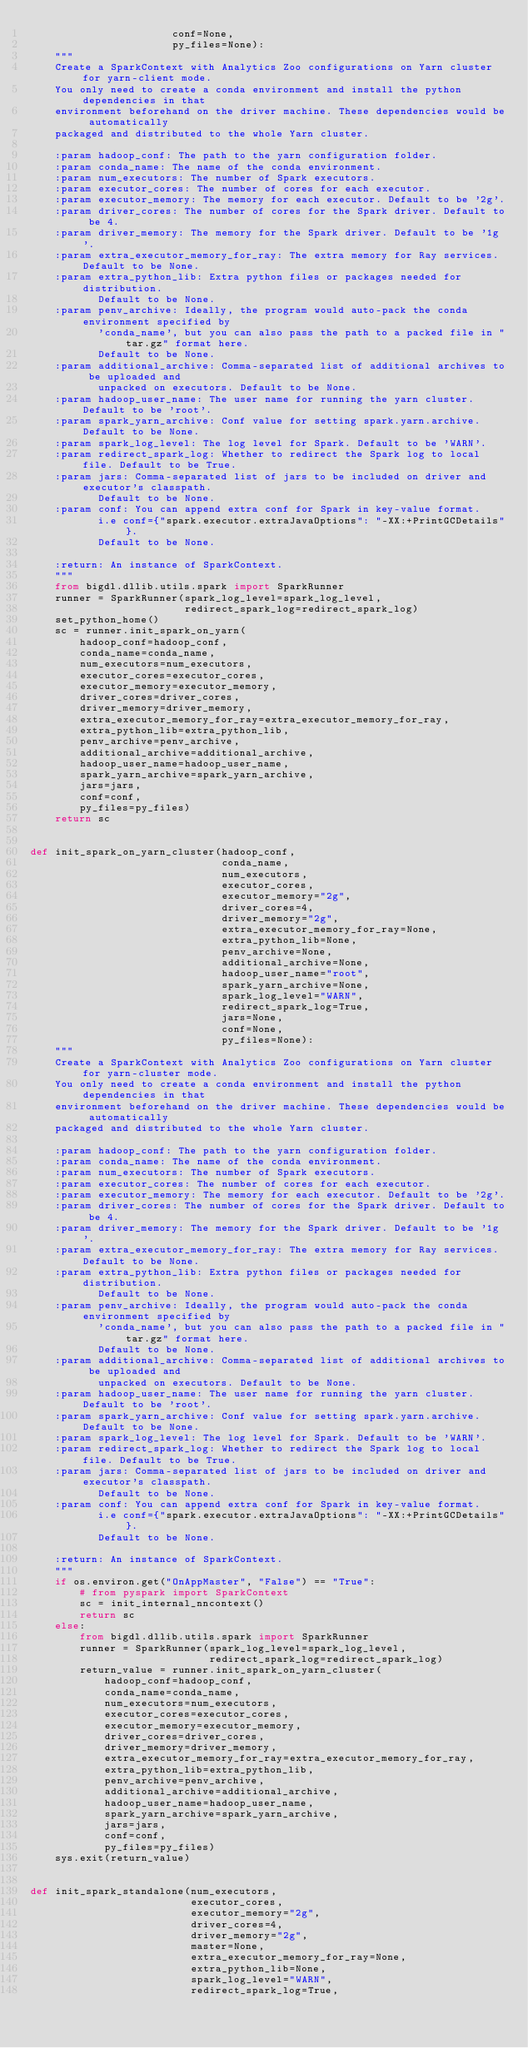Convert code to text. <code><loc_0><loc_0><loc_500><loc_500><_Python_>                       conf=None,
                       py_files=None):
    """
    Create a SparkContext with Analytics Zoo configurations on Yarn cluster for yarn-client mode.
    You only need to create a conda environment and install the python dependencies in that
    environment beforehand on the driver machine. These dependencies would be automatically
    packaged and distributed to the whole Yarn cluster.

    :param hadoop_conf: The path to the yarn configuration folder.
    :param conda_name: The name of the conda environment.
    :param num_executors: The number of Spark executors.
    :param executor_cores: The number of cores for each executor.
    :param executor_memory: The memory for each executor. Default to be '2g'.
    :param driver_cores: The number of cores for the Spark driver. Default to be 4.
    :param driver_memory: The memory for the Spark driver. Default to be '1g'.
    :param extra_executor_memory_for_ray: The extra memory for Ray services. Default to be None.
    :param extra_python_lib: Extra python files or packages needed for distribution.
           Default to be None.
    :param penv_archive: Ideally, the program would auto-pack the conda environment specified by
           'conda_name', but you can also pass the path to a packed file in "tar.gz" format here.
           Default to be None.
    :param additional_archive: Comma-separated list of additional archives to be uploaded and
           unpacked on executors. Default to be None.
    :param hadoop_user_name: The user name for running the yarn cluster. Default to be 'root'.
    :param spark_yarn_archive: Conf value for setting spark.yarn.archive. Default to be None.
    :param spark_log_level: The log level for Spark. Default to be 'WARN'.
    :param redirect_spark_log: Whether to redirect the Spark log to local file. Default to be True.
    :param jars: Comma-separated list of jars to be included on driver and executor's classpath.
           Default to be None.
    :param conf: You can append extra conf for Spark in key-value format.
           i.e conf={"spark.executor.extraJavaOptions": "-XX:+PrintGCDetails"}.
           Default to be None.

    :return: An instance of SparkContext.
    """
    from bigdl.dllib.utils.spark import SparkRunner
    runner = SparkRunner(spark_log_level=spark_log_level,
                         redirect_spark_log=redirect_spark_log)
    set_python_home()
    sc = runner.init_spark_on_yarn(
        hadoop_conf=hadoop_conf,
        conda_name=conda_name,
        num_executors=num_executors,
        executor_cores=executor_cores,
        executor_memory=executor_memory,
        driver_cores=driver_cores,
        driver_memory=driver_memory,
        extra_executor_memory_for_ray=extra_executor_memory_for_ray,
        extra_python_lib=extra_python_lib,
        penv_archive=penv_archive,
        additional_archive=additional_archive,
        hadoop_user_name=hadoop_user_name,
        spark_yarn_archive=spark_yarn_archive,
        jars=jars,
        conf=conf,
        py_files=py_files)
    return sc


def init_spark_on_yarn_cluster(hadoop_conf,
                               conda_name,
                               num_executors,
                               executor_cores,
                               executor_memory="2g",
                               driver_cores=4,
                               driver_memory="2g",
                               extra_executor_memory_for_ray=None,
                               extra_python_lib=None,
                               penv_archive=None,
                               additional_archive=None,
                               hadoop_user_name="root",
                               spark_yarn_archive=None,
                               spark_log_level="WARN",
                               redirect_spark_log=True,
                               jars=None,
                               conf=None,
                               py_files=None):
    """
    Create a SparkContext with Analytics Zoo configurations on Yarn cluster for yarn-cluster mode.
    You only need to create a conda environment and install the python dependencies in that
    environment beforehand on the driver machine. These dependencies would be automatically
    packaged and distributed to the whole Yarn cluster.

    :param hadoop_conf: The path to the yarn configuration folder.
    :param conda_name: The name of the conda environment.
    :param num_executors: The number of Spark executors.
    :param executor_cores: The number of cores for each executor.
    :param executor_memory: The memory for each executor. Default to be '2g'.
    :param driver_cores: The number of cores for the Spark driver. Default to be 4.
    :param driver_memory: The memory for the Spark driver. Default to be '1g'.
    :param extra_executor_memory_for_ray: The extra memory for Ray services. Default to be None.
    :param extra_python_lib: Extra python files or packages needed for distribution.
           Default to be None.
    :param penv_archive: Ideally, the program would auto-pack the conda environment specified by
           'conda_name', but you can also pass the path to a packed file in "tar.gz" format here.
           Default to be None.
    :param additional_archive: Comma-separated list of additional archives to be uploaded and
           unpacked on executors. Default to be None.
    :param hadoop_user_name: The user name for running the yarn cluster. Default to be 'root'.
    :param spark_yarn_archive: Conf value for setting spark.yarn.archive. Default to be None.
    :param spark_log_level: The log level for Spark. Default to be 'WARN'.
    :param redirect_spark_log: Whether to redirect the Spark log to local file. Default to be True.
    :param jars: Comma-separated list of jars to be included on driver and executor's classpath.
           Default to be None.
    :param conf: You can append extra conf for Spark in key-value format.
           i.e conf={"spark.executor.extraJavaOptions": "-XX:+PrintGCDetails"}.
           Default to be None.

    :return: An instance of SparkContext.
    """
    if os.environ.get("OnAppMaster", "False") == "True":
        # from pyspark import SparkContext
        sc = init_internal_nncontext()
        return sc
    else:
        from bigdl.dllib.utils.spark import SparkRunner
        runner = SparkRunner(spark_log_level=spark_log_level,
                             redirect_spark_log=redirect_spark_log)
        return_value = runner.init_spark_on_yarn_cluster(
            hadoop_conf=hadoop_conf,
            conda_name=conda_name,
            num_executors=num_executors,
            executor_cores=executor_cores,
            executor_memory=executor_memory,
            driver_cores=driver_cores,
            driver_memory=driver_memory,
            extra_executor_memory_for_ray=extra_executor_memory_for_ray,
            extra_python_lib=extra_python_lib,
            penv_archive=penv_archive,
            additional_archive=additional_archive,
            hadoop_user_name=hadoop_user_name,
            spark_yarn_archive=spark_yarn_archive,
            jars=jars,
            conf=conf,
            py_files=py_files)
    sys.exit(return_value)


def init_spark_standalone(num_executors,
                          executor_cores,
                          executor_memory="2g",
                          driver_cores=4,
                          driver_memory="2g",
                          master=None,
                          extra_executor_memory_for_ray=None,
                          extra_python_lib=None,
                          spark_log_level="WARN",
                          redirect_spark_log=True,</code> 